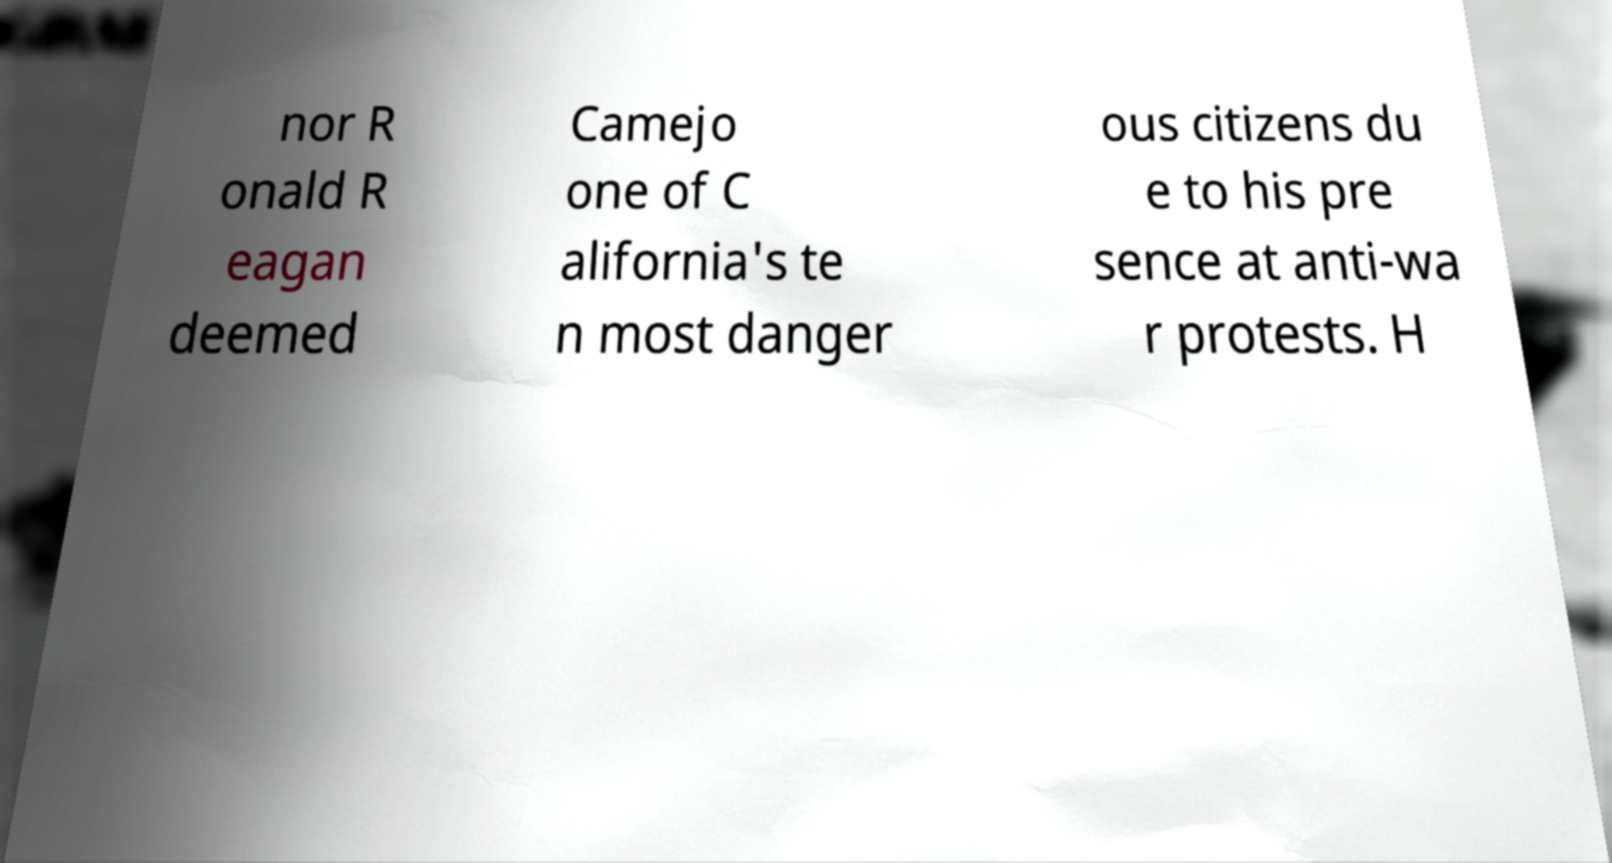Can you accurately transcribe the text from the provided image for me? nor R onald R eagan deemed Camejo one of C alifornia's te n most danger ous citizens du e to his pre sence at anti-wa r protests. H 